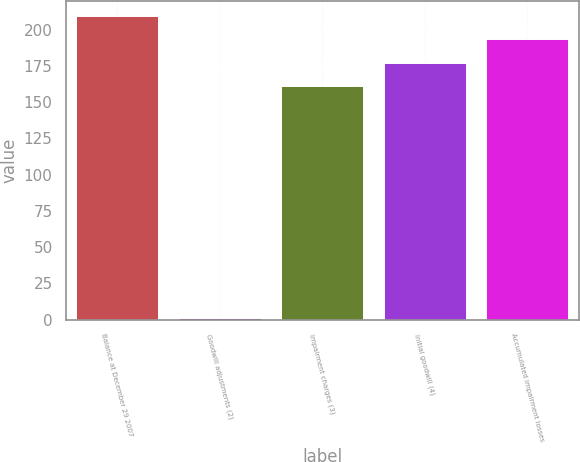Convert chart to OTSL. <chart><loc_0><loc_0><loc_500><loc_500><bar_chart><fcel>Balance at December 29 2007<fcel>Goodwill adjustments (2)<fcel>Impairment charges (3)<fcel>Initial goodwill (4)<fcel>Accumulated impairment losses<nl><fcel>209.3<fcel>1<fcel>161<fcel>177.1<fcel>193.2<nl></chart> 